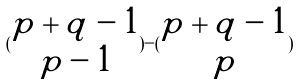Convert formula to latex. <formula><loc_0><loc_0><loc_500><loc_500>( \begin{matrix} p + q - 1 \\ p - 1 \end{matrix} ) - ( \begin{matrix} p + q - 1 \\ p \end{matrix} )</formula> 